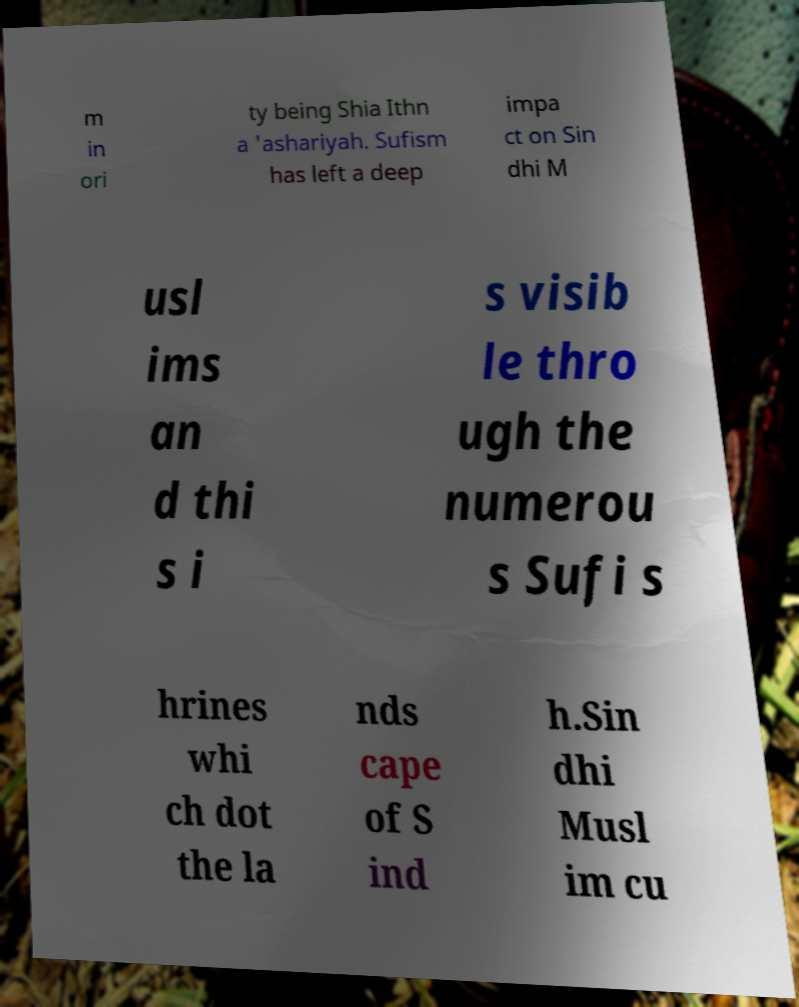What messages or text are displayed in this image? I need them in a readable, typed format. m in ori ty being Shia Ithn a 'ashariyah. Sufism has left a deep impa ct on Sin dhi M usl ims an d thi s i s visib le thro ugh the numerou s Sufi s hrines whi ch dot the la nds cape of S ind h.Sin dhi Musl im cu 